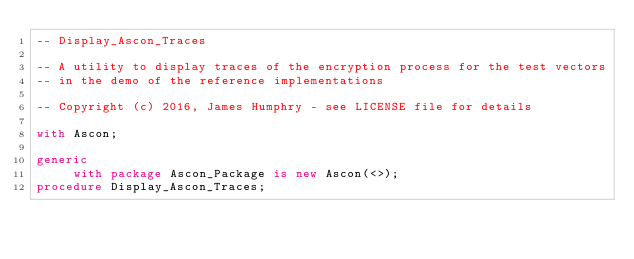<code> <loc_0><loc_0><loc_500><loc_500><_Ada_>-- Display_Ascon_Traces

-- A utility to display traces of the encryption process for the test vectors
-- in the demo of the reference implementations

-- Copyright (c) 2016, James Humphry - see LICENSE file for details

with Ascon;

generic
     with package Ascon_Package is new Ascon(<>);
procedure Display_Ascon_Traces;
</code> 